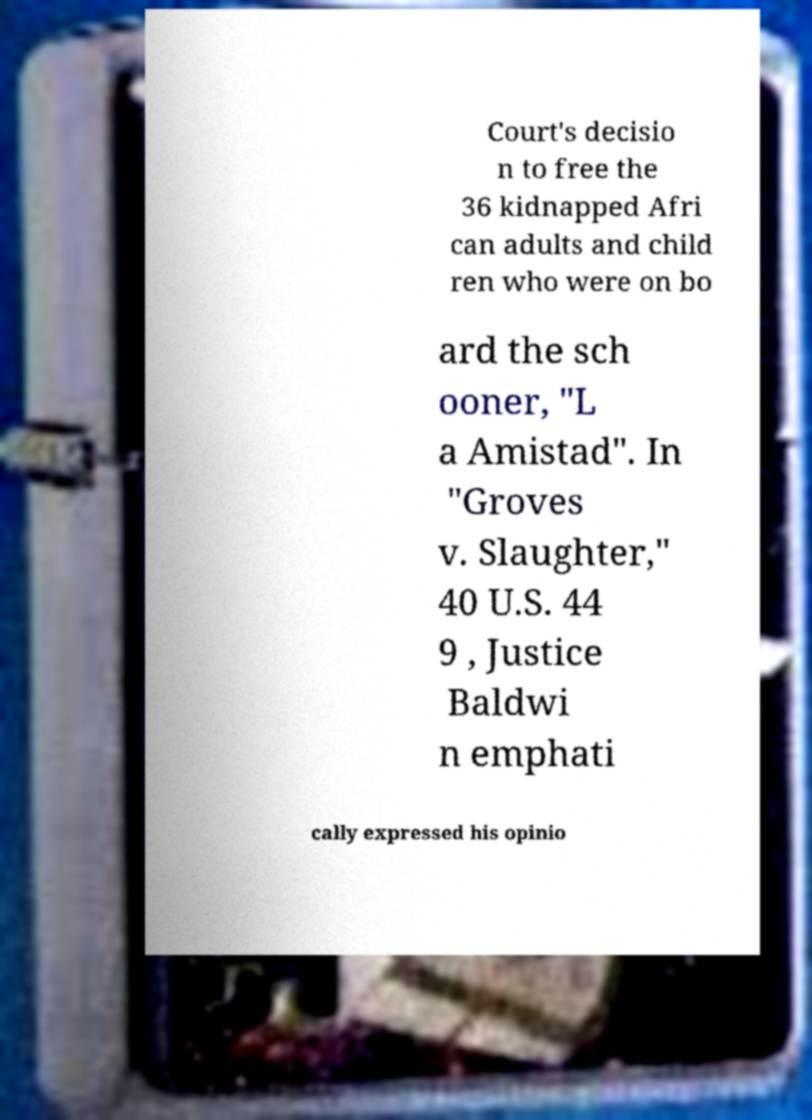Please identify and transcribe the text found in this image. Court's decisio n to free the 36 kidnapped Afri can adults and child ren who were on bo ard the sch ooner, "L a Amistad". In "Groves v. Slaughter," 40 U.S. 44 9 , Justice Baldwi n emphati cally expressed his opinio 